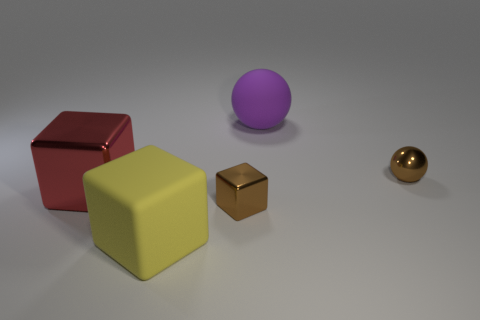How many large things are either matte objects or purple spheres?
Provide a succinct answer. 2. Is the shape of the big red object the same as the yellow matte object?
Your answer should be compact. Yes. What number of things are left of the large purple rubber sphere and behind the large yellow cube?
Offer a very short reply. 2. Is there anything else of the same color as the large metallic cube?
Offer a very short reply. No. What is the shape of the brown thing that is made of the same material as the brown cube?
Your answer should be compact. Sphere. Is the size of the red block the same as the brown metal sphere?
Your answer should be compact. No. Does the small brown object to the left of the large purple rubber object have the same material as the large yellow object?
Keep it short and to the point. No. Is there anything else that has the same material as the brown cube?
Your answer should be very brief. Yes. There is a large rubber thing behind the large matte thing in front of the tiny brown metallic sphere; how many brown metal objects are to the right of it?
Offer a very short reply. 1. Does the matte object in front of the purple sphere have the same shape as the red object?
Your response must be concise. Yes. 